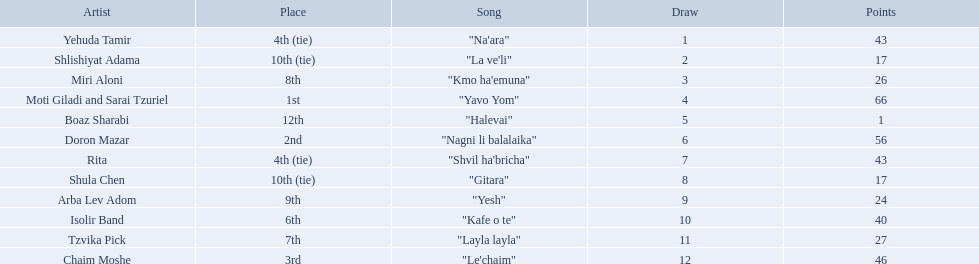Who were all the artists at the contest? Yehuda Tamir, Shlishiyat Adama, Miri Aloni, Moti Giladi and Sarai Tzuriel, Boaz Sharabi, Doron Mazar, Rita, Shula Chen, Arba Lev Adom, Isolir Band, Tzvika Pick, Chaim Moshe. What were their point totals? 43, 17, 26, 66, 1, 56, 43, 17, 24, 40, 27, 46. Of these, which is the least amount of points? 1. Which artists received this point total? Boaz Sharabi. What are the points? 43, 17, 26, 66, 1, 56, 43, 17, 24, 40, 27, 46. What is the least? 1. Which artist has that much Boaz Sharabi. 